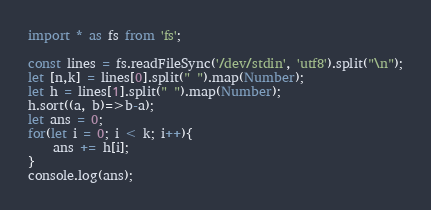<code> <loc_0><loc_0><loc_500><loc_500><_TypeScript_>import * as fs from 'fs';
 
const lines = fs.readFileSync('/dev/stdin', 'utf8').split("\n");
let [n,k] = lines[0].split(" ").map(Number);
let h = lines[1].split(" ").map(Number);
h.sort((a, b)=>b-a);
let ans = 0;
for(let i = 0; i < k; i++){
    ans += h[i];
}
console.log(ans);
</code> 